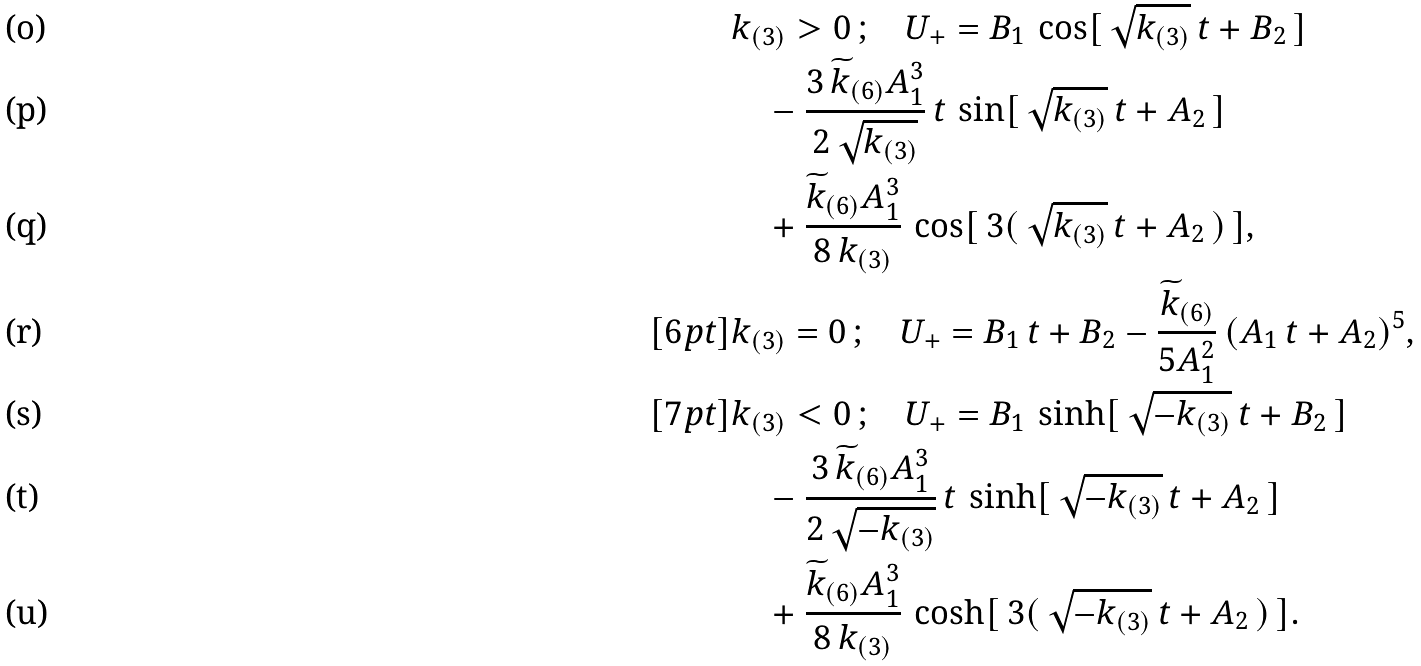<formula> <loc_0><loc_0><loc_500><loc_500>& k _ { ( 3 ) } > 0 \, ; \quad U _ { + } = B _ { 1 } \, \cos [ \, \sqrt { k _ { ( 3 ) } } \, t + B _ { 2 } \, ] \\ & \quad - \frac { 3 \, \widetilde { k } _ { ( 6 ) } A _ { 1 } ^ { 3 } } { 2 \, \sqrt { k _ { ( 3 ) } } } \, t \, \sin [ \, \sqrt { k _ { ( 3 ) } } \, t + A _ { 2 } \, ] \\ & \quad + \frac { \widetilde { k } _ { ( 6 ) } A ^ { 3 } _ { 1 } } { 8 \, k _ { ( 3 ) } } \, \cos [ \, 3 ( \, \sqrt { k _ { ( 3 ) } } \, t + A _ { 2 } \, ) \, ] , \\ [ 6 p t ] & k _ { ( 3 ) } = 0 \, ; \quad U _ { + } = B _ { 1 } \, t + B _ { 2 } - \frac { \widetilde { k } _ { ( 6 ) } } { 5 A ^ { 2 } _ { 1 } } \, ( A _ { 1 } \, t + A _ { 2 } ) ^ { 5 } , \\ [ 7 p t ] & k _ { ( 3 ) } < 0 \, ; \quad U _ { + } = B _ { 1 } \, \sinh [ \, \sqrt { - k _ { ( 3 ) } } \, t + B _ { 2 } \, ] \\ & \quad - \frac { 3 \, \widetilde { k } _ { ( 6 ) } A _ { 1 } ^ { 3 } } { 2 \, \sqrt { - k _ { ( 3 ) } } } \, t \, \sinh [ \, \sqrt { - k _ { ( 3 ) } } \, t + A _ { 2 } \, ] \\ & \quad + \frac { \widetilde { k } _ { ( 6 ) } A ^ { 3 } _ { 1 } } { 8 \, k _ { ( 3 ) } } \, \cosh [ \, 3 ( \, \sqrt { - k _ { ( 3 ) } } \, t + A _ { 2 } \, ) \, ] .</formula> 